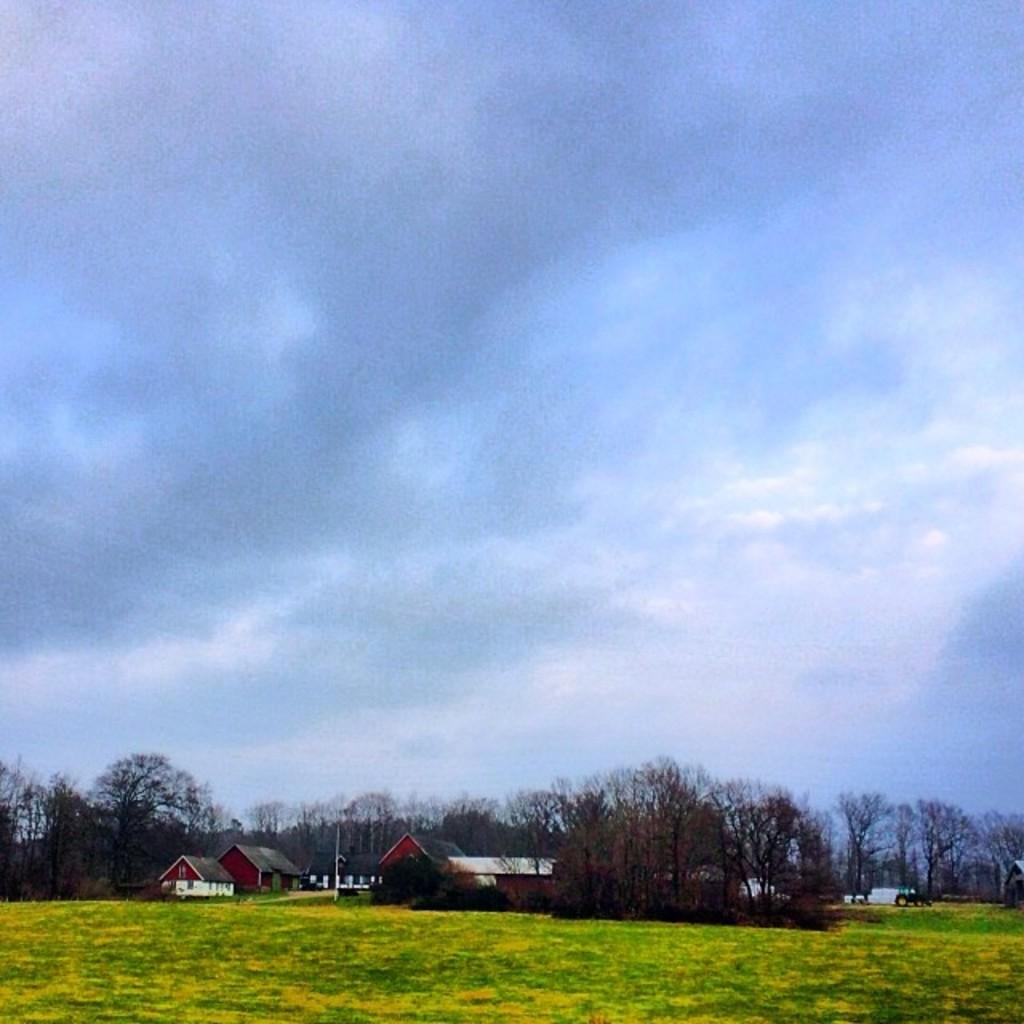What type of vegetation is present on the ground in the image? There is grass on the ground in the image. What can be seen in the background of the image? There are houses and trees in the background of the image. What is visible in the sky in the image? There are clouds in the sky, and the sky is blue. What type of mint is growing near the bed in the image? There is no mint or bed present in the image. 